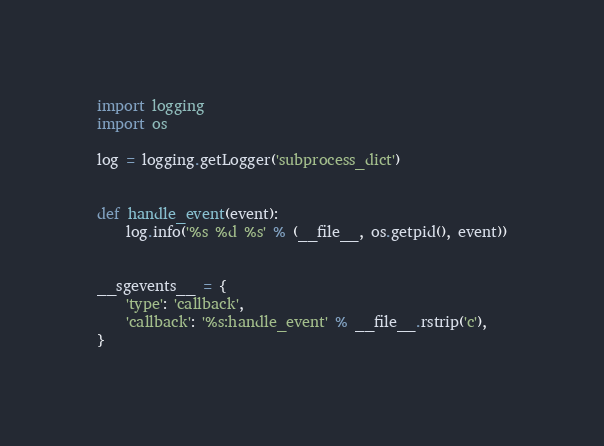<code> <loc_0><loc_0><loc_500><loc_500><_Python_>import logging
import os

log = logging.getLogger('subprocess_dict')


def handle_event(event):
    log.info('%s %d %s' % (__file__, os.getpid(), event))


__sgevents__ = {
    'type': 'callback',
    'callback': '%s:handle_event' % __file__.rstrip('c'),
}


</code> 